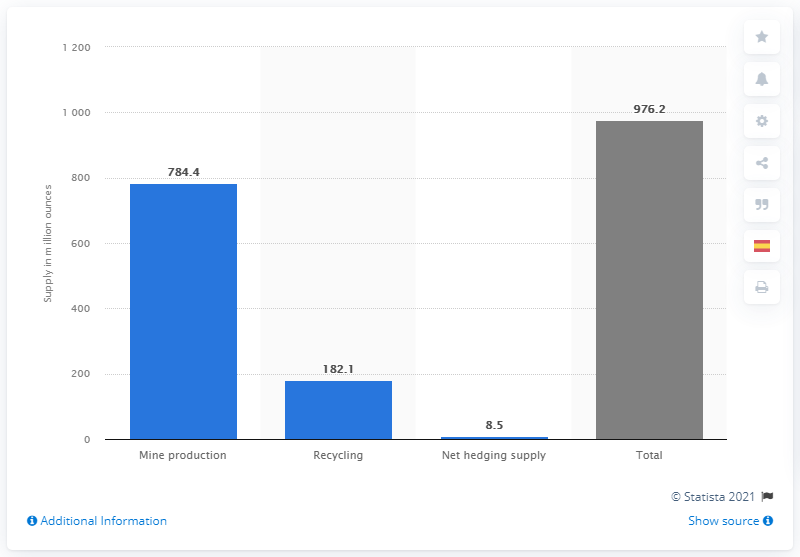Specify some key components in this picture. In 2020, approximately 182.1% of the global silver supply was obtained through recycling. In 2020, the total production of silver from mines was 784.4... 